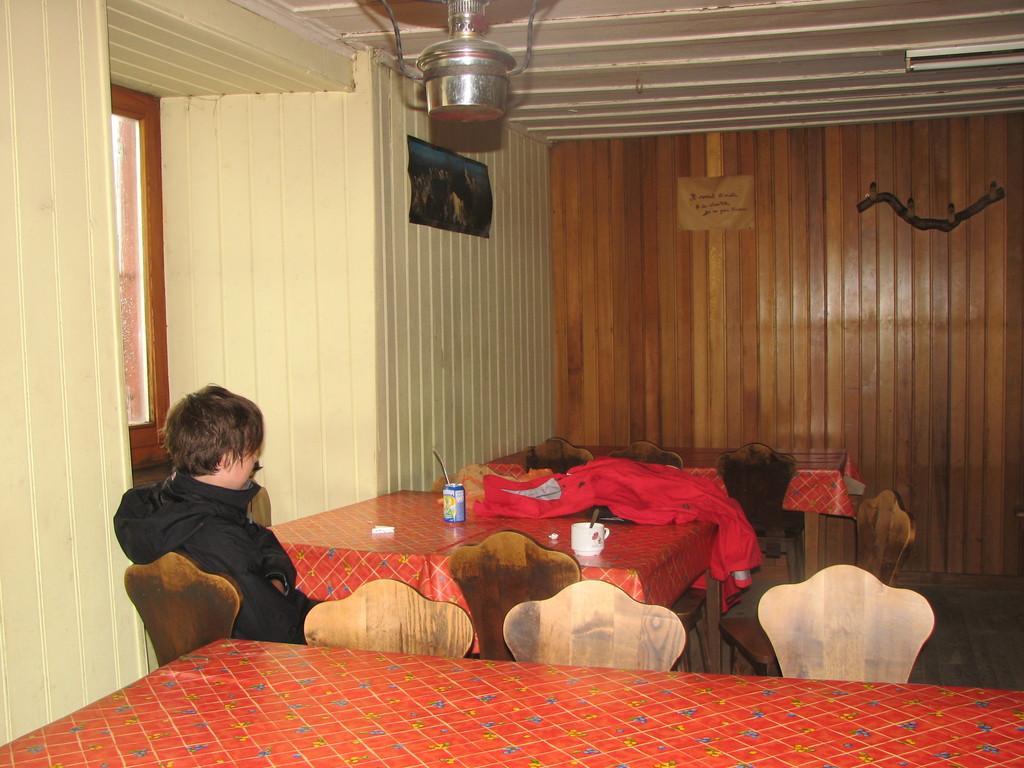How would you summarize this image in a sentence or two? In this picture I can see a person sitting on the chair, in front of the table and also I can see some tables and chairs. 